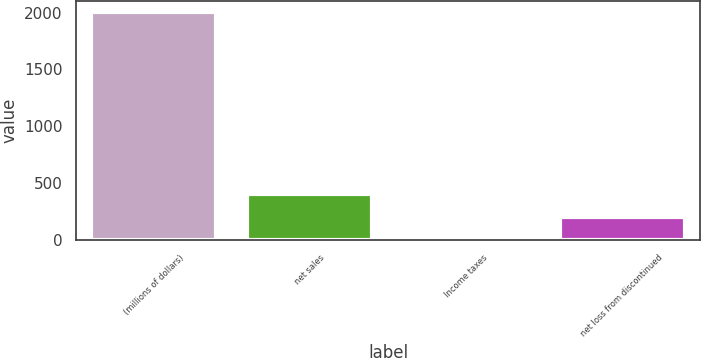<chart> <loc_0><loc_0><loc_500><loc_500><bar_chart><fcel>(millions of dollars)<fcel>net sales<fcel>Income taxes<fcel>net loss from discontinued<nl><fcel>2006<fcel>401.28<fcel>0.1<fcel>200.69<nl></chart> 